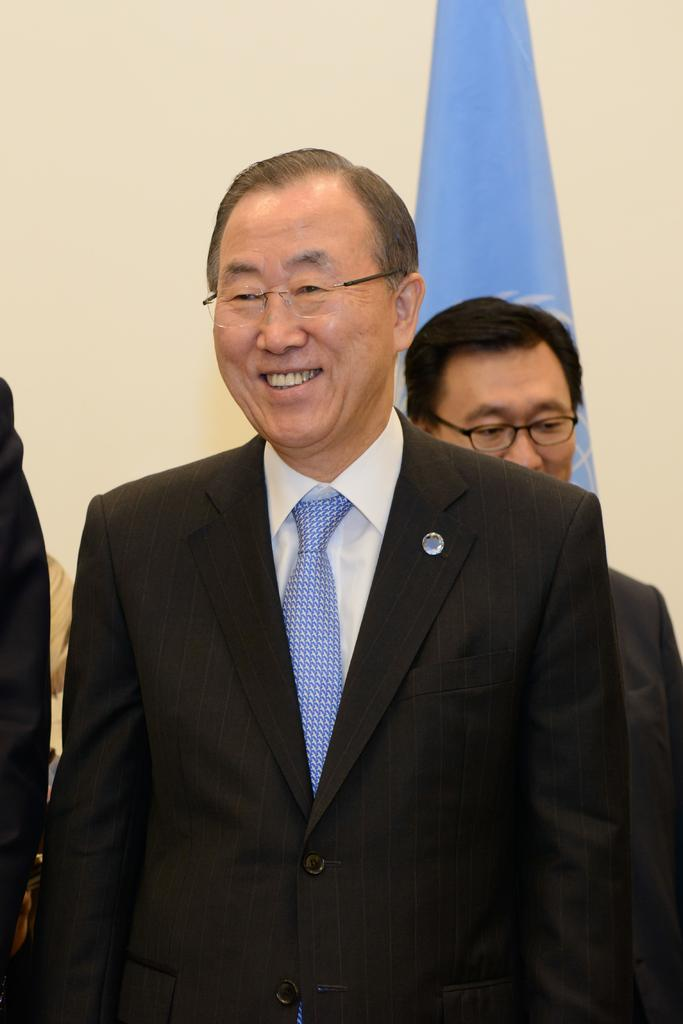How many people are in the image? There are two persons in the image. What are the two persons doing in the image? The two persons are standing. What type of mine can be seen in the background of the image? There is no mine present in the image; it only features two standing persons. 